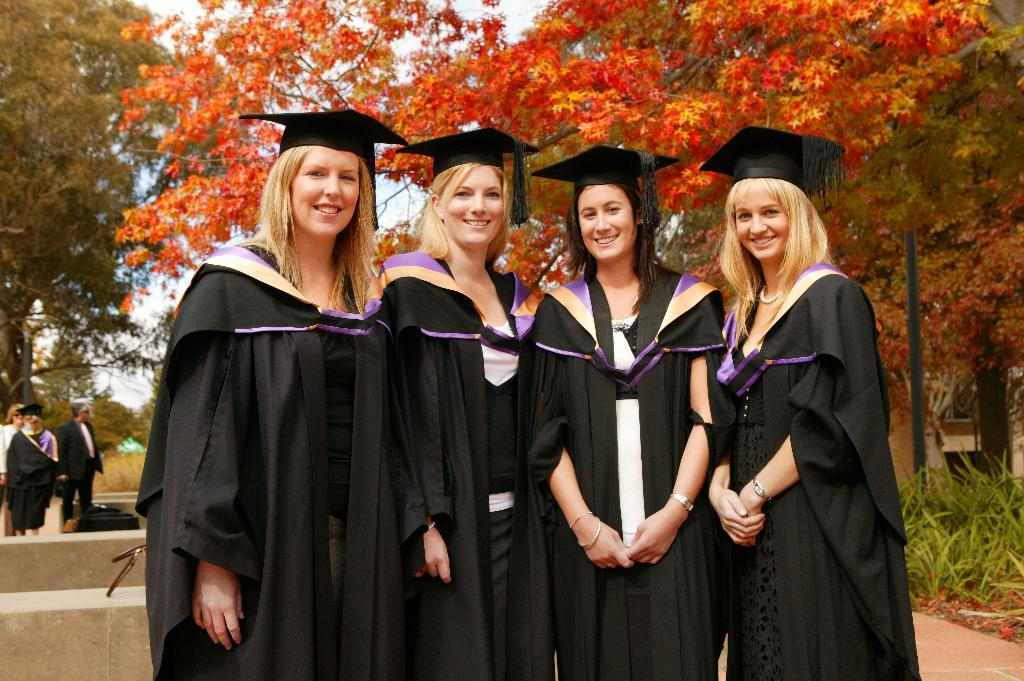How many women are in the image? There are 4 women in the image. What are the women doing in the image? The women are standing in the front and smiling. What are the women wearing in the image? The women are wearing graduation day dress. Are there any other people in the image besides the women? Yes, there are other people in the image. What else can be seen in the background of the image? There are poles and trees in the image. Can you tell me how many horses are visible in the image? There are no horses present in the image. What type of flame can be seen coming from the women's eyes in the image? There is no flame coming from the women's eyes in the image; they are simply smiling. 